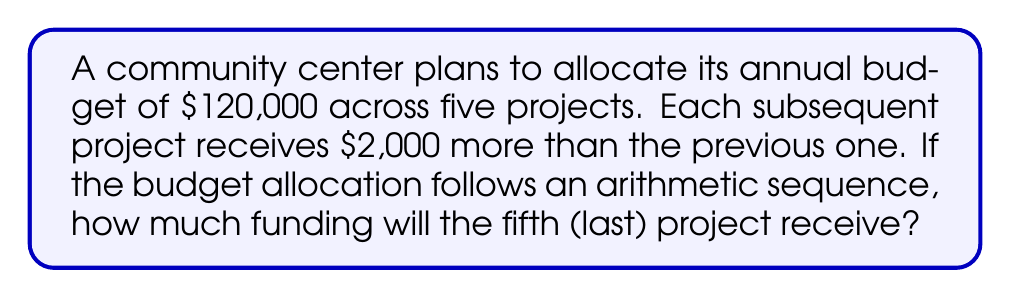Can you solve this math problem? Let's approach this step-by-step:

1) Let $a$ be the amount allocated to the first project, and $d = 2000$ be the common difference between consecutive allocations.

2) The arithmetic sequence for the five projects is:
   $a, a+d, a+2d, a+3d, a+4d$

3) The sum of this arithmetic sequence should equal the total budget:
   $$(a) + (a+d) + (a+2d) + (a+3d) + (a+4d) = 120000$$

4) Simplify the left side of the equation:
   $$5a + 10d = 120000$$

5) Substitute $d = 2000$:
   $$5a + 10(2000) = 120000$$
   $$5a + 20000 = 120000$$
   $$5a = 100000$$
   $$a = 20000$$

6) Now we know the first project receives $20,000. To find the fifth project's allocation, we use the formula for the nth term of an arithmetic sequence:
   $$a_n = a + (n-1)d$$
   $$a_5 = 20000 + (5-1)(2000)$$
   $$a_5 = 20000 + 8000 = 28000$$

Therefore, the fifth project will receive $28,000.
Answer: $28,000 